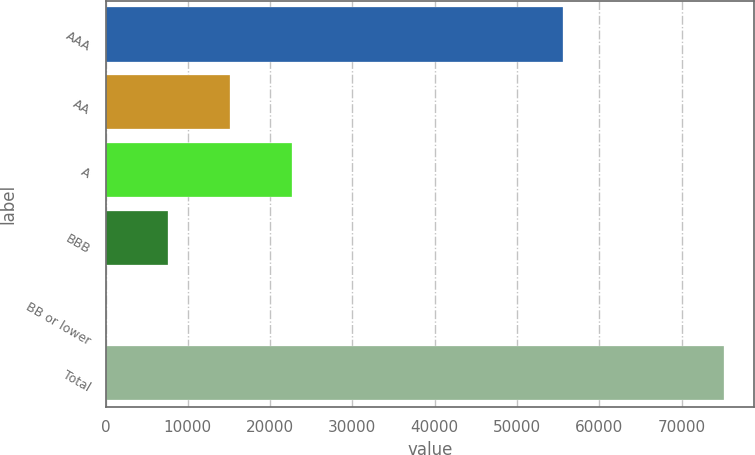Convert chart to OTSL. <chart><loc_0><loc_0><loc_500><loc_500><bar_chart><fcel>AAA<fcel>AA<fcel>A<fcel>BBB<fcel>BB or lower<fcel>Total<nl><fcel>55626<fcel>15097<fcel>22598<fcel>7596<fcel>95<fcel>75105<nl></chart> 